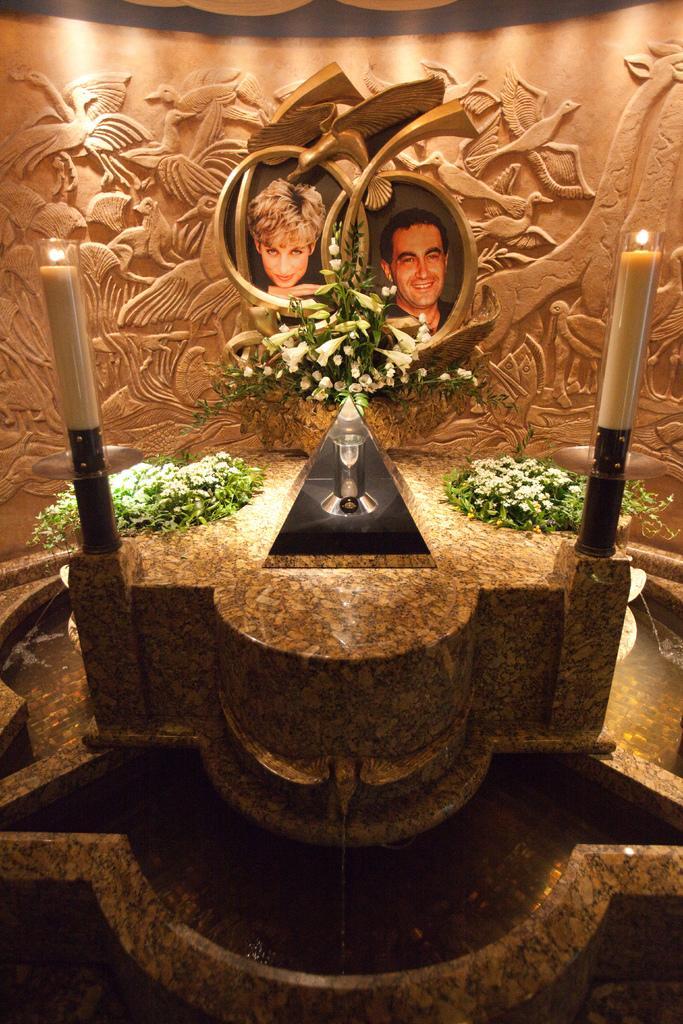Can you describe this image briefly? In this picture we can see candles, water, flowers, photos of a man and a woman and in the background we can see the wall with designs. 